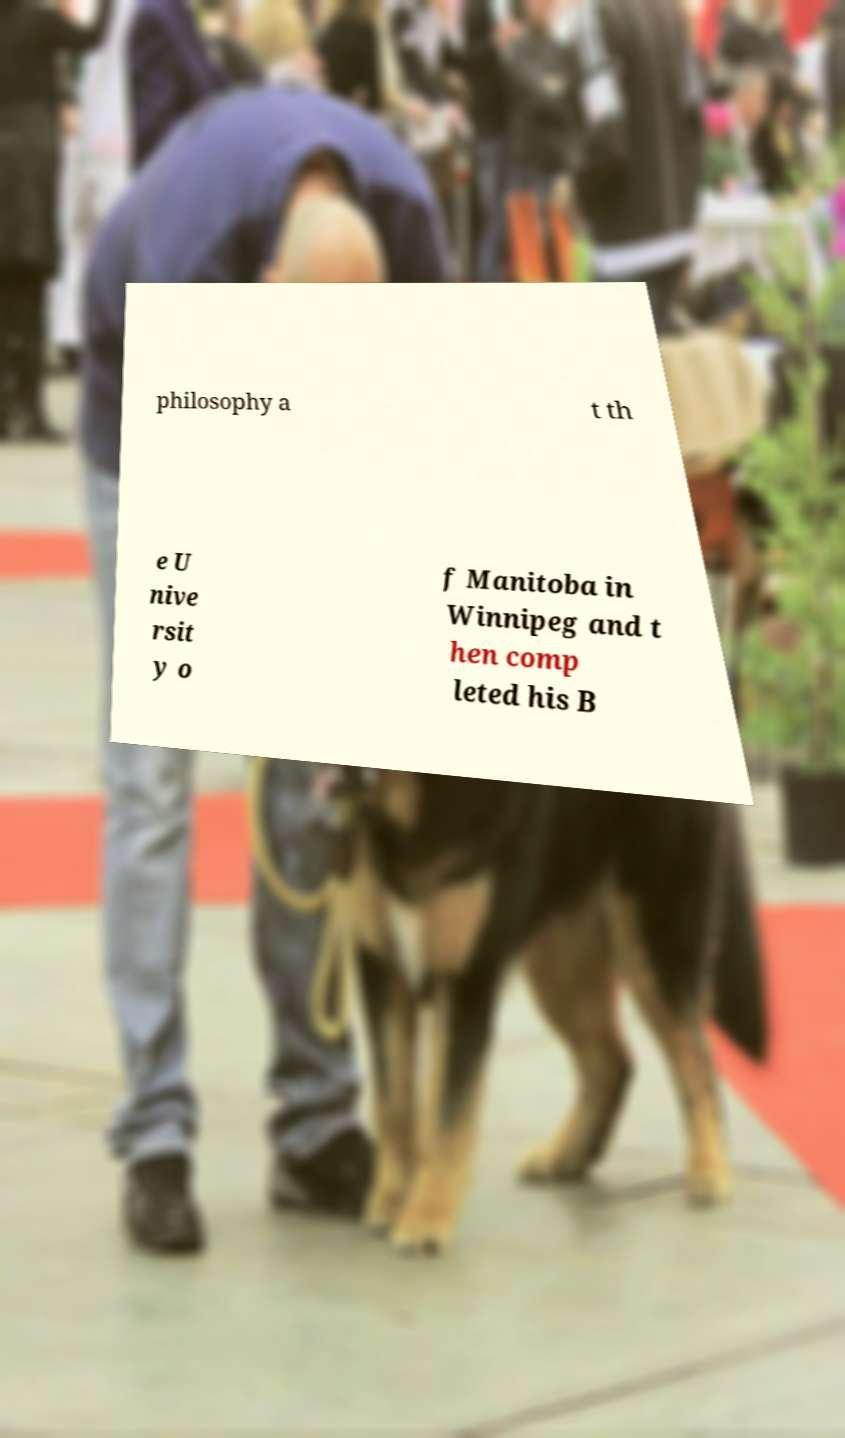For documentation purposes, I need the text within this image transcribed. Could you provide that? philosophy a t th e U nive rsit y o f Manitoba in Winnipeg and t hen comp leted his B 